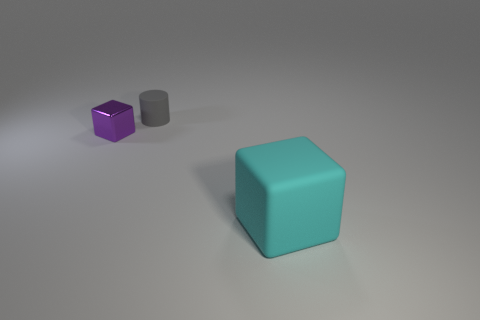Is there anything else that is the same size as the cyan object?
Your answer should be compact. No. Does the block to the left of the gray matte thing have the same size as the cylinder?
Your answer should be compact. Yes. What number of matte objects are either cylinders or blue objects?
Make the answer very short. 1. There is a rubber object that is behind the cyan thing; how many large matte things are in front of it?
Ensure brevity in your answer.  1. The object that is behind the big cyan block and in front of the gray cylinder has what shape?
Provide a succinct answer. Cube. There is a block on the right side of the thing behind the block that is to the left of the cyan rubber thing; what is it made of?
Ensure brevity in your answer.  Rubber. What material is the small gray cylinder?
Offer a terse response. Rubber. Do the tiny purple thing and the thing that is on the right side of the tiny rubber cylinder have the same material?
Offer a very short reply. No. What is the color of the cube left of the cube right of the gray rubber cylinder?
Provide a short and direct response. Purple. What is the size of the thing that is both in front of the tiny gray cylinder and on the right side of the purple thing?
Provide a short and direct response. Large. 